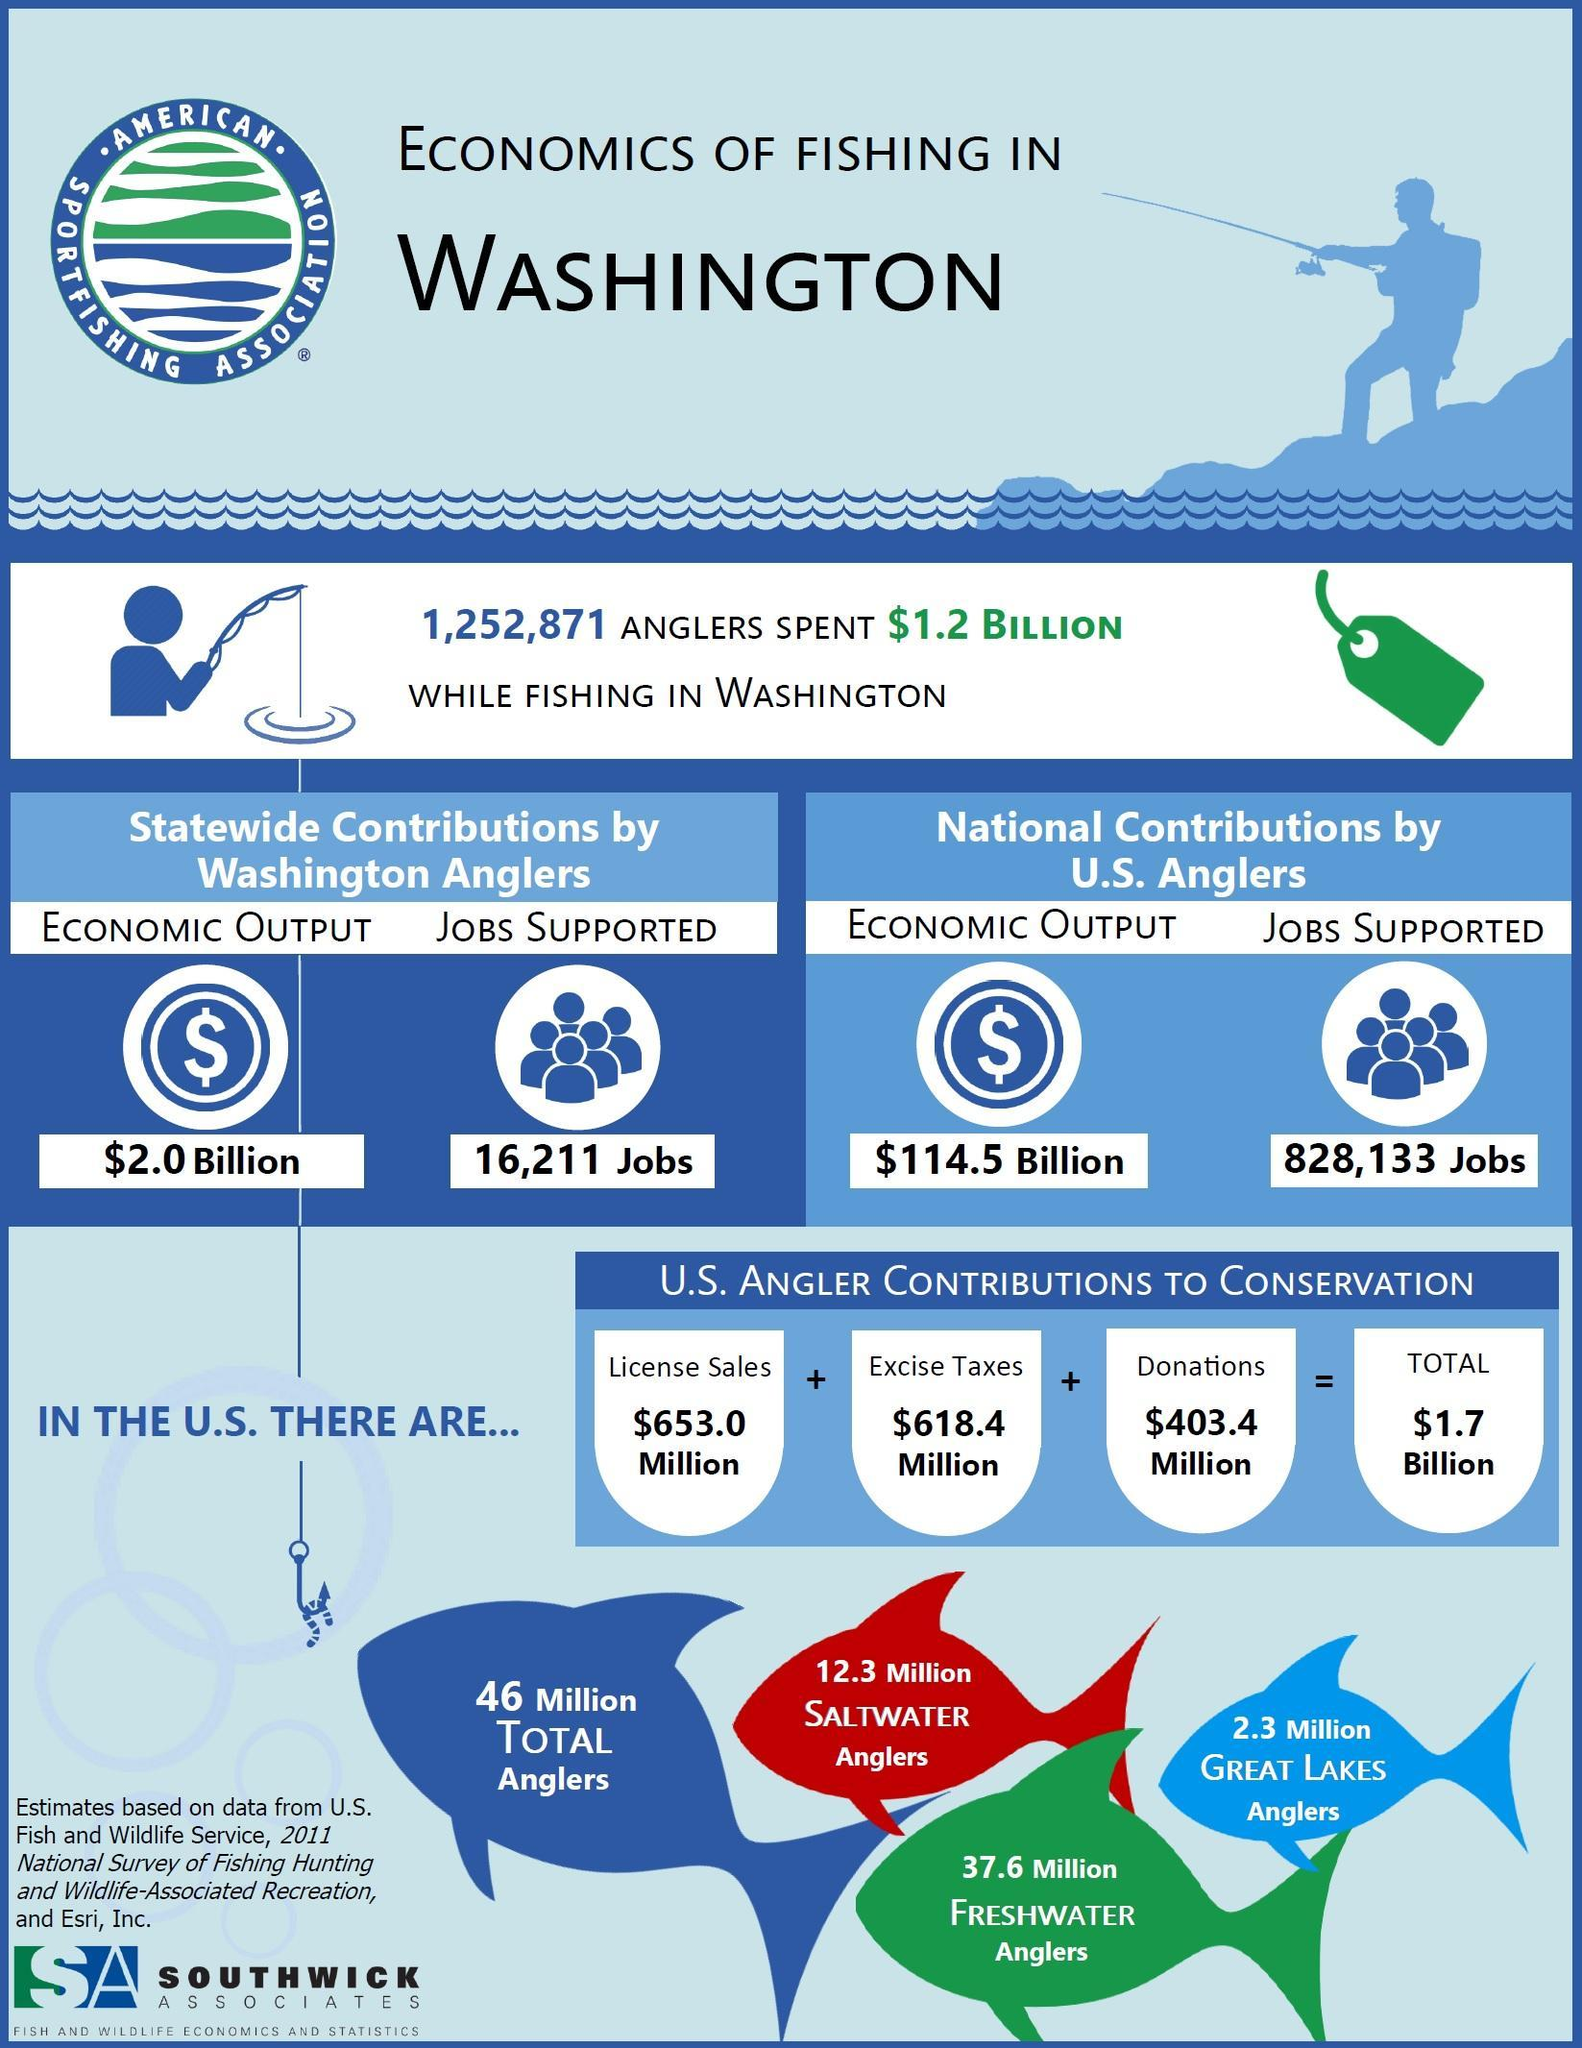What is the economic output from the statewide contributions by Washington anglers?
Answer the question with a short phrase. $2.0 Billion What is the total number of saltwater and freshwater anglers in U.S.? 49.9 Million What is the total contribution in license sales and excise taxes from U.S. anglers? 1.2714 Billion What is the difference in economic output from the statewide contributions by Washington anglers and National contributions by U.S. Anglers?? $112.5 Billion 